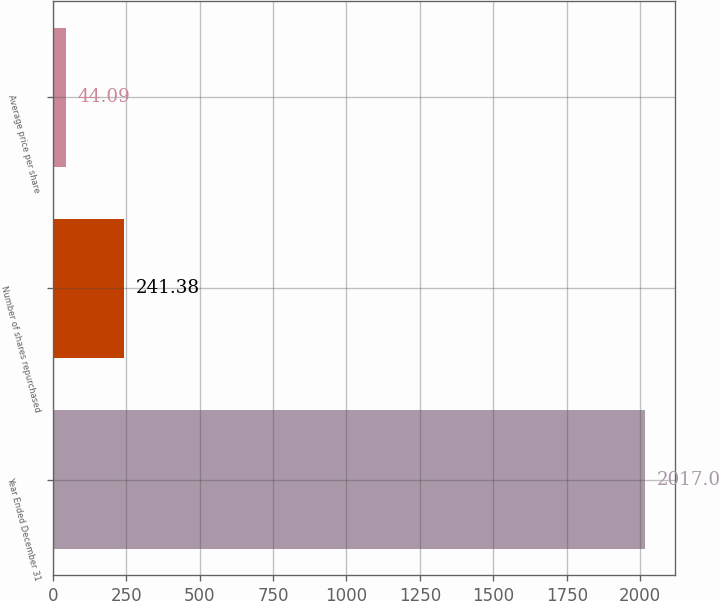<chart> <loc_0><loc_0><loc_500><loc_500><bar_chart><fcel>Year Ended December 31<fcel>Number of shares repurchased<fcel>Average price per share<nl><fcel>2017<fcel>241.38<fcel>44.09<nl></chart> 